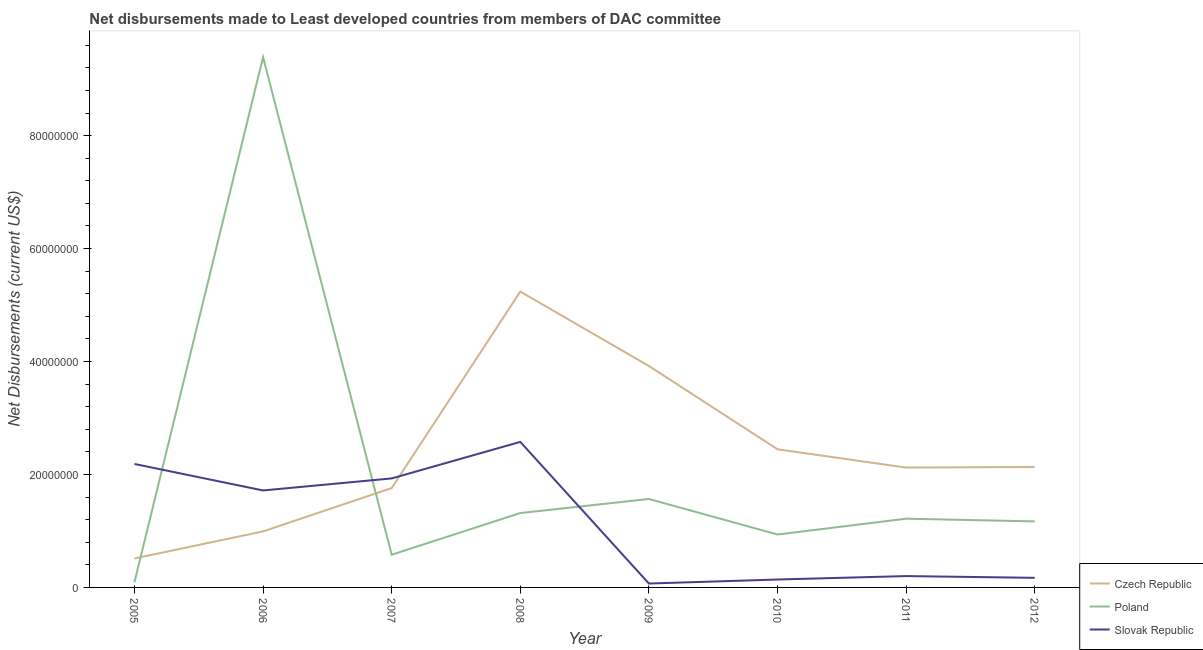How many different coloured lines are there?
Keep it short and to the point. 3. What is the net disbursements made by slovak republic in 2010?
Your answer should be very brief. 1.40e+06. Across all years, what is the maximum net disbursements made by czech republic?
Make the answer very short. 5.24e+07. Across all years, what is the minimum net disbursements made by czech republic?
Make the answer very short. 5.13e+06. What is the total net disbursements made by czech republic in the graph?
Your answer should be very brief. 1.91e+08. What is the difference between the net disbursements made by slovak republic in 2010 and that in 2012?
Ensure brevity in your answer.  -3.00e+05. What is the difference between the net disbursements made by poland in 2007 and the net disbursements made by czech republic in 2009?
Your response must be concise. -3.34e+07. What is the average net disbursements made by poland per year?
Provide a short and direct response. 2.03e+07. In the year 2011, what is the difference between the net disbursements made by czech republic and net disbursements made by poland?
Offer a terse response. 9.05e+06. In how many years, is the net disbursements made by slovak republic greater than 24000000 US$?
Ensure brevity in your answer.  1. What is the ratio of the net disbursements made by czech republic in 2006 to that in 2007?
Keep it short and to the point. 0.56. What is the difference between the highest and the second highest net disbursements made by poland?
Your answer should be very brief. 7.82e+07. What is the difference between the highest and the lowest net disbursements made by poland?
Ensure brevity in your answer.  9.30e+07. Is the sum of the net disbursements made by poland in 2008 and 2012 greater than the maximum net disbursements made by czech republic across all years?
Your answer should be compact. No. Does the net disbursements made by poland monotonically increase over the years?
Make the answer very short. No. Is the net disbursements made by poland strictly greater than the net disbursements made by czech republic over the years?
Provide a succinct answer. No. How many lines are there?
Provide a succinct answer. 3. Are the values on the major ticks of Y-axis written in scientific E-notation?
Make the answer very short. No. Does the graph contain any zero values?
Your answer should be compact. No. Where does the legend appear in the graph?
Ensure brevity in your answer.  Bottom right. How many legend labels are there?
Provide a succinct answer. 3. What is the title of the graph?
Offer a very short reply. Net disbursements made to Least developed countries from members of DAC committee. Does "Coal" appear as one of the legend labels in the graph?
Make the answer very short. No. What is the label or title of the Y-axis?
Your answer should be very brief. Net Disbursements (current US$). What is the Net Disbursements (current US$) of Czech Republic in 2005?
Your answer should be very brief. 5.13e+06. What is the Net Disbursements (current US$) in Poland in 2005?
Offer a very short reply. 9.30e+05. What is the Net Disbursements (current US$) of Slovak Republic in 2005?
Make the answer very short. 2.19e+07. What is the Net Disbursements (current US$) of Czech Republic in 2006?
Make the answer very short. 9.92e+06. What is the Net Disbursements (current US$) of Poland in 2006?
Provide a short and direct response. 9.39e+07. What is the Net Disbursements (current US$) of Slovak Republic in 2006?
Provide a short and direct response. 1.72e+07. What is the Net Disbursements (current US$) of Czech Republic in 2007?
Offer a very short reply. 1.76e+07. What is the Net Disbursements (current US$) in Poland in 2007?
Offer a terse response. 5.79e+06. What is the Net Disbursements (current US$) of Slovak Republic in 2007?
Offer a terse response. 1.93e+07. What is the Net Disbursements (current US$) of Czech Republic in 2008?
Make the answer very short. 5.24e+07. What is the Net Disbursements (current US$) of Poland in 2008?
Provide a succinct answer. 1.32e+07. What is the Net Disbursements (current US$) of Slovak Republic in 2008?
Give a very brief answer. 2.58e+07. What is the Net Disbursements (current US$) in Czech Republic in 2009?
Make the answer very short. 3.92e+07. What is the Net Disbursements (current US$) in Poland in 2009?
Your answer should be compact. 1.57e+07. What is the Net Disbursements (current US$) in Slovak Republic in 2009?
Your response must be concise. 6.90e+05. What is the Net Disbursements (current US$) of Czech Republic in 2010?
Your answer should be very brief. 2.45e+07. What is the Net Disbursements (current US$) in Poland in 2010?
Your answer should be very brief. 9.37e+06. What is the Net Disbursements (current US$) of Slovak Republic in 2010?
Offer a terse response. 1.40e+06. What is the Net Disbursements (current US$) in Czech Republic in 2011?
Offer a terse response. 2.12e+07. What is the Net Disbursements (current US$) in Poland in 2011?
Make the answer very short. 1.22e+07. What is the Net Disbursements (current US$) of Slovak Republic in 2011?
Give a very brief answer. 2.01e+06. What is the Net Disbursements (current US$) in Czech Republic in 2012?
Make the answer very short. 2.13e+07. What is the Net Disbursements (current US$) of Poland in 2012?
Ensure brevity in your answer.  1.17e+07. What is the Net Disbursements (current US$) in Slovak Republic in 2012?
Your response must be concise. 1.70e+06. Across all years, what is the maximum Net Disbursements (current US$) of Czech Republic?
Keep it short and to the point. 5.24e+07. Across all years, what is the maximum Net Disbursements (current US$) of Poland?
Make the answer very short. 9.39e+07. Across all years, what is the maximum Net Disbursements (current US$) in Slovak Republic?
Make the answer very short. 2.58e+07. Across all years, what is the minimum Net Disbursements (current US$) of Czech Republic?
Make the answer very short. 5.13e+06. Across all years, what is the minimum Net Disbursements (current US$) in Poland?
Your answer should be very brief. 9.30e+05. Across all years, what is the minimum Net Disbursements (current US$) in Slovak Republic?
Your response must be concise. 6.90e+05. What is the total Net Disbursements (current US$) of Czech Republic in the graph?
Provide a short and direct response. 1.91e+08. What is the total Net Disbursements (current US$) in Poland in the graph?
Provide a succinct answer. 1.63e+08. What is the total Net Disbursements (current US$) in Slovak Republic in the graph?
Make the answer very short. 8.99e+07. What is the difference between the Net Disbursements (current US$) of Czech Republic in 2005 and that in 2006?
Your answer should be very brief. -4.79e+06. What is the difference between the Net Disbursements (current US$) of Poland in 2005 and that in 2006?
Ensure brevity in your answer.  -9.30e+07. What is the difference between the Net Disbursements (current US$) of Slovak Republic in 2005 and that in 2006?
Your answer should be compact. 4.69e+06. What is the difference between the Net Disbursements (current US$) in Czech Republic in 2005 and that in 2007?
Your answer should be compact. -1.25e+07. What is the difference between the Net Disbursements (current US$) in Poland in 2005 and that in 2007?
Keep it short and to the point. -4.86e+06. What is the difference between the Net Disbursements (current US$) of Slovak Republic in 2005 and that in 2007?
Ensure brevity in your answer.  2.56e+06. What is the difference between the Net Disbursements (current US$) in Czech Republic in 2005 and that in 2008?
Your answer should be compact. -4.72e+07. What is the difference between the Net Disbursements (current US$) of Poland in 2005 and that in 2008?
Offer a terse response. -1.22e+07. What is the difference between the Net Disbursements (current US$) in Slovak Republic in 2005 and that in 2008?
Provide a succinct answer. -3.91e+06. What is the difference between the Net Disbursements (current US$) in Czech Republic in 2005 and that in 2009?
Give a very brief answer. -3.41e+07. What is the difference between the Net Disbursements (current US$) of Poland in 2005 and that in 2009?
Keep it short and to the point. -1.47e+07. What is the difference between the Net Disbursements (current US$) of Slovak Republic in 2005 and that in 2009?
Your answer should be compact. 2.12e+07. What is the difference between the Net Disbursements (current US$) of Czech Republic in 2005 and that in 2010?
Provide a succinct answer. -1.93e+07. What is the difference between the Net Disbursements (current US$) of Poland in 2005 and that in 2010?
Your answer should be very brief. -8.44e+06. What is the difference between the Net Disbursements (current US$) of Slovak Republic in 2005 and that in 2010?
Provide a succinct answer. 2.05e+07. What is the difference between the Net Disbursements (current US$) of Czech Republic in 2005 and that in 2011?
Provide a succinct answer. -1.61e+07. What is the difference between the Net Disbursements (current US$) in Poland in 2005 and that in 2011?
Make the answer very short. -1.12e+07. What is the difference between the Net Disbursements (current US$) in Slovak Republic in 2005 and that in 2011?
Offer a terse response. 1.98e+07. What is the difference between the Net Disbursements (current US$) in Czech Republic in 2005 and that in 2012?
Give a very brief answer. -1.62e+07. What is the difference between the Net Disbursements (current US$) in Poland in 2005 and that in 2012?
Offer a very short reply. -1.08e+07. What is the difference between the Net Disbursements (current US$) in Slovak Republic in 2005 and that in 2012?
Your answer should be compact. 2.02e+07. What is the difference between the Net Disbursements (current US$) of Czech Republic in 2006 and that in 2007?
Give a very brief answer. -7.67e+06. What is the difference between the Net Disbursements (current US$) of Poland in 2006 and that in 2007?
Your answer should be compact. 8.81e+07. What is the difference between the Net Disbursements (current US$) of Slovak Republic in 2006 and that in 2007?
Your response must be concise. -2.13e+06. What is the difference between the Net Disbursements (current US$) in Czech Republic in 2006 and that in 2008?
Your answer should be compact. -4.25e+07. What is the difference between the Net Disbursements (current US$) in Poland in 2006 and that in 2008?
Provide a succinct answer. 8.07e+07. What is the difference between the Net Disbursements (current US$) of Slovak Republic in 2006 and that in 2008?
Offer a terse response. -8.60e+06. What is the difference between the Net Disbursements (current US$) in Czech Republic in 2006 and that in 2009?
Ensure brevity in your answer.  -2.93e+07. What is the difference between the Net Disbursements (current US$) of Poland in 2006 and that in 2009?
Offer a very short reply. 7.82e+07. What is the difference between the Net Disbursements (current US$) in Slovak Republic in 2006 and that in 2009?
Offer a very short reply. 1.65e+07. What is the difference between the Net Disbursements (current US$) in Czech Republic in 2006 and that in 2010?
Offer a very short reply. -1.45e+07. What is the difference between the Net Disbursements (current US$) of Poland in 2006 and that in 2010?
Offer a very short reply. 8.45e+07. What is the difference between the Net Disbursements (current US$) of Slovak Republic in 2006 and that in 2010?
Make the answer very short. 1.58e+07. What is the difference between the Net Disbursements (current US$) of Czech Republic in 2006 and that in 2011?
Offer a very short reply. -1.13e+07. What is the difference between the Net Disbursements (current US$) of Poland in 2006 and that in 2011?
Your answer should be compact. 8.17e+07. What is the difference between the Net Disbursements (current US$) of Slovak Republic in 2006 and that in 2011?
Your answer should be compact. 1.52e+07. What is the difference between the Net Disbursements (current US$) in Czech Republic in 2006 and that in 2012?
Your response must be concise. -1.14e+07. What is the difference between the Net Disbursements (current US$) in Poland in 2006 and that in 2012?
Ensure brevity in your answer.  8.22e+07. What is the difference between the Net Disbursements (current US$) in Slovak Republic in 2006 and that in 2012?
Provide a succinct answer. 1.55e+07. What is the difference between the Net Disbursements (current US$) of Czech Republic in 2007 and that in 2008?
Your response must be concise. -3.48e+07. What is the difference between the Net Disbursements (current US$) in Poland in 2007 and that in 2008?
Offer a terse response. -7.38e+06. What is the difference between the Net Disbursements (current US$) of Slovak Republic in 2007 and that in 2008?
Your answer should be compact. -6.47e+06. What is the difference between the Net Disbursements (current US$) of Czech Republic in 2007 and that in 2009?
Offer a terse response. -2.16e+07. What is the difference between the Net Disbursements (current US$) in Poland in 2007 and that in 2009?
Your answer should be compact. -9.87e+06. What is the difference between the Net Disbursements (current US$) of Slovak Republic in 2007 and that in 2009?
Offer a very short reply. 1.86e+07. What is the difference between the Net Disbursements (current US$) in Czech Republic in 2007 and that in 2010?
Keep it short and to the point. -6.87e+06. What is the difference between the Net Disbursements (current US$) of Poland in 2007 and that in 2010?
Ensure brevity in your answer.  -3.58e+06. What is the difference between the Net Disbursements (current US$) of Slovak Republic in 2007 and that in 2010?
Make the answer very short. 1.79e+07. What is the difference between the Net Disbursements (current US$) in Czech Republic in 2007 and that in 2011?
Make the answer very short. -3.63e+06. What is the difference between the Net Disbursements (current US$) in Poland in 2007 and that in 2011?
Your answer should be very brief. -6.38e+06. What is the difference between the Net Disbursements (current US$) in Slovak Republic in 2007 and that in 2011?
Your answer should be very brief. 1.73e+07. What is the difference between the Net Disbursements (current US$) in Czech Republic in 2007 and that in 2012?
Offer a terse response. -3.74e+06. What is the difference between the Net Disbursements (current US$) in Poland in 2007 and that in 2012?
Your answer should be very brief. -5.90e+06. What is the difference between the Net Disbursements (current US$) in Slovak Republic in 2007 and that in 2012?
Offer a very short reply. 1.76e+07. What is the difference between the Net Disbursements (current US$) in Czech Republic in 2008 and that in 2009?
Offer a very short reply. 1.32e+07. What is the difference between the Net Disbursements (current US$) of Poland in 2008 and that in 2009?
Offer a very short reply. -2.49e+06. What is the difference between the Net Disbursements (current US$) in Slovak Republic in 2008 and that in 2009?
Offer a terse response. 2.51e+07. What is the difference between the Net Disbursements (current US$) of Czech Republic in 2008 and that in 2010?
Ensure brevity in your answer.  2.79e+07. What is the difference between the Net Disbursements (current US$) in Poland in 2008 and that in 2010?
Keep it short and to the point. 3.80e+06. What is the difference between the Net Disbursements (current US$) in Slovak Republic in 2008 and that in 2010?
Your answer should be compact. 2.44e+07. What is the difference between the Net Disbursements (current US$) of Czech Republic in 2008 and that in 2011?
Your answer should be very brief. 3.12e+07. What is the difference between the Net Disbursements (current US$) of Poland in 2008 and that in 2011?
Make the answer very short. 1.00e+06. What is the difference between the Net Disbursements (current US$) of Slovak Republic in 2008 and that in 2011?
Make the answer very short. 2.38e+07. What is the difference between the Net Disbursements (current US$) in Czech Republic in 2008 and that in 2012?
Provide a succinct answer. 3.10e+07. What is the difference between the Net Disbursements (current US$) of Poland in 2008 and that in 2012?
Offer a very short reply. 1.48e+06. What is the difference between the Net Disbursements (current US$) of Slovak Republic in 2008 and that in 2012?
Your response must be concise. 2.41e+07. What is the difference between the Net Disbursements (current US$) in Czech Republic in 2009 and that in 2010?
Your answer should be very brief. 1.48e+07. What is the difference between the Net Disbursements (current US$) of Poland in 2009 and that in 2010?
Ensure brevity in your answer.  6.29e+06. What is the difference between the Net Disbursements (current US$) in Slovak Republic in 2009 and that in 2010?
Ensure brevity in your answer.  -7.10e+05. What is the difference between the Net Disbursements (current US$) in Czech Republic in 2009 and that in 2011?
Provide a short and direct response. 1.80e+07. What is the difference between the Net Disbursements (current US$) of Poland in 2009 and that in 2011?
Provide a succinct answer. 3.49e+06. What is the difference between the Net Disbursements (current US$) of Slovak Republic in 2009 and that in 2011?
Offer a terse response. -1.32e+06. What is the difference between the Net Disbursements (current US$) of Czech Republic in 2009 and that in 2012?
Keep it short and to the point. 1.79e+07. What is the difference between the Net Disbursements (current US$) in Poland in 2009 and that in 2012?
Provide a short and direct response. 3.97e+06. What is the difference between the Net Disbursements (current US$) of Slovak Republic in 2009 and that in 2012?
Offer a terse response. -1.01e+06. What is the difference between the Net Disbursements (current US$) in Czech Republic in 2010 and that in 2011?
Provide a succinct answer. 3.24e+06. What is the difference between the Net Disbursements (current US$) in Poland in 2010 and that in 2011?
Your response must be concise. -2.80e+06. What is the difference between the Net Disbursements (current US$) in Slovak Republic in 2010 and that in 2011?
Your answer should be compact. -6.10e+05. What is the difference between the Net Disbursements (current US$) of Czech Republic in 2010 and that in 2012?
Give a very brief answer. 3.13e+06. What is the difference between the Net Disbursements (current US$) of Poland in 2010 and that in 2012?
Offer a very short reply. -2.32e+06. What is the difference between the Net Disbursements (current US$) in Slovak Republic in 2010 and that in 2012?
Your response must be concise. -3.00e+05. What is the difference between the Net Disbursements (current US$) in Czech Republic in 2011 and that in 2012?
Your answer should be very brief. -1.10e+05. What is the difference between the Net Disbursements (current US$) of Czech Republic in 2005 and the Net Disbursements (current US$) of Poland in 2006?
Give a very brief answer. -8.88e+07. What is the difference between the Net Disbursements (current US$) of Czech Republic in 2005 and the Net Disbursements (current US$) of Slovak Republic in 2006?
Offer a terse response. -1.20e+07. What is the difference between the Net Disbursements (current US$) in Poland in 2005 and the Net Disbursements (current US$) in Slovak Republic in 2006?
Your answer should be very brief. -1.62e+07. What is the difference between the Net Disbursements (current US$) in Czech Republic in 2005 and the Net Disbursements (current US$) in Poland in 2007?
Offer a terse response. -6.60e+05. What is the difference between the Net Disbursements (current US$) of Czech Republic in 2005 and the Net Disbursements (current US$) of Slovak Republic in 2007?
Provide a succinct answer. -1.42e+07. What is the difference between the Net Disbursements (current US$) in Poland in 2005 and the Net Disbursements (current US$) in Slovak Republic in 2007?
Your answer should be very brief. -1.84e+07. What is the difference between the Net Disbursements (current US$) in Czech Republic in 2005 and the Net Disbursements (current US$) in Poland in 2008?
Your answer should be compact. -8.04e+06. What is the difference between the Net Disbursements (current US$) in Czech Republic in 2005 and the Net Disbursements (current US$) in Slovak Republic in 2008?
Offer a very short reply. -2.06e+07. What is the difference between the Net Disbursements (current US$) of Poland in 2005 and the Net Disbursements (current US$) of Slovak Republic in 2008?
Your answer should be very brief. -2.48e+07. What is the difference between the Net Disbursements (current US$) in Czech Republic in 2005 and the Net Disbursements (current US$) in Poland in 2009?
Give a very brief answer. -1.05e+07. What is the difference between the Net Disbursements (current US$) in Czech Republic in 2005 and the Net Disbursements (current US$) in Slovak Republic in 2009?
Give a very brief answer. 4.44e+06. What is the difference between the Net Disbursements (current US$) of Poland in 2005 and the Net Disbursements (current US$) of Slovak Republic in 2009?
Your response must be concise. 2.40e+05. What is the difference between the Net Disbursements (current US$) of Czech Republic in 2005 and the Net Disbursements (current US$) of Poland in 2010?
Provide a succinct answer. -4.24e+06. What is the difference between the Net Disbursements (current US$) of Czech Republic in 2005 and the Net Disbursements (current US$) of Slovak Republic in 2010?
Offer a very short reply. 3.73e+06. What is the difference between the Net Disbursements (current US$) in Poland in 2005 and the Net Disbursements (current US$) in Slovak Republic in 2010?
Keep it short and to the point. -4.70e+05. What is the difference between the Net Disbursements (current US$) of Czech Republic in 2005 and the Net Disbursements (current US$) of Poland in 2011?
Keep it short and to the point. -7.04e+06. What is the difference between the Net Disbursements (current US$) of Czech Republic in 2005 and the Net Disbursements (current US$) of Slovak Republic in 2011?
Make the answer very short. 3.12e+06. What is the difference between the Net Disbursements (current US$) in Poland in 2005 and the Net Disbursements (current US$) in Slovak Republic in 2011?
Provide a short and direct response. -1.08e+06. What is the difference between the Net Disbursements (current US$) in Czech Republic in 2005 and the Net Disbursements (current US$) in Poland in 2012?
Your response must be concise. -6.56e+06. What is the difference between the Net Disbursements (current US$) of Czech Republic in 2005 and the Net Disbursements (current US$) of Slovak Republic in 2012?
Make the answer very short. 3.43e+06. What is the difference between the Net Disbursements (current US$) of Poland in 2005 and the Net Disbursements (current US$) of Slovak Republic in 2012?
Offer a terse response. -7.70e+05. What is the difference between the Net Disbursements (current US$) in Czech Republic in 2006 and the Net Disbursements (current US$) in Poland in 2007?
Give a very brief answer. 4.13e+06. What is the difference between the Net Disbursements (current US$) of Czech Republic in 2006 and the Net Disbursements (current US$) of Slovak Republic in 2007?
Keep it short and to the point. -9.38e+06. What is the difference between the Net Disbursements (current US$) in Poland in 2006 and the Net Disbursements (current US$) in Slovak Republic in 2007?
Provide a succinct answer. 7.46e+07. What is the difference between the Net Disbursements (current US$) in Czech Republic in 2006 and the Net Disbursements (current US$) in Poland in 2008?
Offer a very short reply. -3.25e+06. What is the difference between the Net Disbursements (current US$) in Czech Republic in 2006 and the Net Disbursements (current US$) in Slovak Republic in 2008?
Give a very brief answer. -1.58e+07. What is the difference between the Net Disbursements (current US$) of Poland in 2006 and the Net Disbursements (current US$) of Slovak Republic in 2008?
Your answer should be compact. 6.81e+07. What is the difference between the Net Disbursements (current US$) of Czech Republic in 2006 and the Net Disbursements (current US$) of Poland in 2009?
Give a very brief answer. -5.74e+06. What is the difference between the Net Disbursements (current US$) in Czech Republic in 2006 and the Net Disbursements (current US$) in Slovak Republic in 2009?
Provide a succinct answer. 9.23e+06. What is the difference between the Net Disbursements (current US$) in Poland in 2006 and the Net Disbursements (current US$) in Slovak Republic in 2009?
Your answer should be compact. 9.32e+07. What is the difference between the Net Disbursements (current US$) of Czech Republic in 2006 and the Net Disbursements (current US$) of Poland in 2010?
Your answer should be very brief. 5.50e+05. What is the difference between the Net Disbursements (current US$) of Czech Republic in 2006 and the Net Disbursements (current US$) of Slovak Republic in 2010?
Offer a terse response. 8.52e+06. What is the difference between the Net Disbursements (current US$) of Poland in 2006 and the Net Disbursements (current US$) of Slovak Republic in 2010?
Ensure brevity in your answer.  9.25e+07. What is the difference between the Net Disbursements (current US$) in Czech Republic in 2006 and the Net Disbursements (current US$) in Poland in 2011?
Offer a very short reply. -2.25e+06. What is the difference between the Net Disbursements (current US$) in Czech Republic in 2006 and the Net Disbursements (current US$) in Slovak Republic in 2011?
Offer a terse response. 7.91e+06. What is the difference between the Net Disbursements (current US$) in Poland in 2006 and the Net Disbursements (current US$) in Slovak Republic in 2011?
Give a very brief answer. 9.19e+07. What is the difference between the Net Disbursements (current US$) in Czech Republic in 2006 and the Net Disbursements (current US$) in Poland in 2012?
Provide a succinct answer. -1.77e+06. What is the difference between the Net Disbursements (current US$) in Czech Republic in 2006 and the Net Disbursements (current US$) in Slovak Republic in 2012?
Give a very brief answer. 8.22e+06. What is the difference between the Net Disbursements (current US$) in Poland in 2006 and the Net Disbursements (current US$) in Slovak Republic in 2012?
Your answer should be compact. 9.22e+07. What is the difference between the Net Disbursements (current US$) of Czech Republic in 2007 and the Net Disbursements (current US$) of Poland in 2008?
Your response must be concise. 4.42e+06. What is the difference between the Net Disbursements (current US$) of Czech Republic in 2007 and the Net Disbursements (current US$) of Slovak Republic in 2008?
Your response must be concise. -8.18e+06. What is the difference between the Net Disbursements (current US$) of Poland in 2007 and the Net Disbursements (current US$) of Slovak Republic in 2008?
Provide a succinct answer. -2.00e+07. What is the difference between the Net Disbursements (current US$) of Czech Republic in 2007 and the Net Disbursements (current US$) of Poland in 2009?
Provide a succinct answer. 1.93e+06. What is the difference between the Net Disbursements (current US$) of Czech Republic in 2007 and the Net Disbursements (current US$) of Slovak Republic in 2009?
Your answer should be compact. 1.69e+07. What is the difference between the Net Disbursements (current US$) of Poland in 2007 and the Net Disbursements (current US$) of Slovak Republic in 2009?
Provide a short and direct response. 5.10e+06. What is the difference between the Net Disbursements (current US$) of Czech Republic in 2007 and the Net Disbursements (current US$) of Poland in 2010?
Your response must be concise. 8.22e+06. What is the difference between the Net Disbursements (current US$) of Czech Republic in 2007 and the Net Disbursements (current US$) of Slovak Republic in 2010?
Your response must be concise. 1.62e+07. What is the difference between the Net Disbursements (current US$) in Poland in 2007 and the Net Disbursements (current US$) in Slovak Republic in 2010?
Your response must be concise. 4.39e+06. What is the difference between the Net Disbursements (current US$) of Czech Republic in 2007 and the Net Disbursements (current US$) of Poland in 2011?
Keep it short and to the point. 5.42e+06. What is the difference between the Net Disbursements (current US$) of Czech Republic in 2007 and the Net Disbursements (current US$) of Slovak Republic in 2011?
Make the answer very short. 1.56e+07. What is the difference between the Net Disbursements (current US$) of Poland in 2007 and the Net Disbursements (current US$) of Slovak Republic in 2011?
Provide a short and direct response. 3.78e+06. What is the difference between the Net Disbursements (current US$) in Czech Republic in 2007 and the Net Disbursements (current US$) in Poland in 2012?
Offer a very short reply. 5.90e+06. What is the difference between the Net Disbursements (current US$) of Czech Republic in 2007 and the Net Disbursements (current US$) of Slovak Republic in 2012?
Provide a succinct answer. 1.59e+07. What is the difference between the Net Disbursements (current US$) in Poland in 2007 and the Net Disbursements (current US$) in Slovak Republic in 2012?
Provide a succinct answer. 4.09e+06. What is the difference between the Net Disbursements (current US$) of Czech Republic in 2008 and the Net Disbursements (current US$) of Poland in 2009?
Offer a very short reply. 3.67e+07. What is the difference between the Net Disbursements (current US$) of Czech Republic in 2008 and the Net Disbursements (current US$) of Slovak Republic in 2009?
Your answer should be compact. 5.17e+07. What is the difference between the Net Disbursements (current US$) of Poland in 2008 and the Net Disbursements (current US$) of Slovak Republic in 2009?
Provide a succinct answer. 1.25e+07. What is the difference between the Net Disbursements (current US$) of Czech Republic in 2008 and the Net Disbursements (current US$) of Poland in 2010?
Your answer should be compact. 4.30e+07. What is the difference between the Net Disbursements (current US$) of Czech Republic in 2008 and the Net Disbursements (current US$) of Slovak Republic in 2010?
Your response must be concise. 5.10e+07. What is the difference between the Net Disbursements (current US$) of Poland in 2008 and the Net Disbursements (current US$) of Slovak Republic in 2010?
Make the answer very short. 1.18e+07. What is the difference between the Net Disbursements (current US$) of Czech Republic in 2008 and the Net Disbursements (current US$) of Poland in 2011?
Offer a terse response. 4.02e+07. What is the difference between the Net Disbursements (current US$) in Czech Republic in 2008 and the Net Disbursements (current US$) in Slovak Republic in 2011?
Make the answer very short. 5.04e+07. What is the difference between the Net Disbursements (current US$) of Poland in 2008 and the Net Disbursements (current US$) of Slovak Republic in 2011?
Give a very brief answer. 1.12e+07. What is the difference between the Net Disbursements (current US$) of Czech Republic in 2008 and the Net Disbursements (current US$) of Poland in 2012?
Make the answer very short. 4.07e+07. What is the difference between the Net Disbursements (current US$) of Czech Republic in 2008 and the Net Disbursements (current US$) of Slovak Republic in 2012?
Provide a succinct answer. 5.07e+07. What is the difference between the Net Disbursements (current US$) of Poland in 2008 and the Net Disbursements (current US$) of Slovak Republic in 2012?
Give a very brief answer. 1.15e+07. What is the difference between the Net Disbursements (current US$) in Czech Republic in 2009 and the Net Disbursements (current US$) in Poland in 2010?
Keep it short and to the point. 2.98e+07. What is the difference between the Net Disbursements (current US$) in Czech Republic in 2009 and the Net Disbursements (current US$) in Slovak Republic in 2010?
Your response must be concise. 3.78e+07. What is the difference between the Net Disbursements (current US$) of Poland in 2009 and the Net Disbursements (current US$) of Slovak Republic in 2010?
Offer a very short reply. 1.43e+07. What is the difference between the Net Disbursements (current US$) of Czech Republic in 2009 and the Net Disbursements (current US$) of Poland in 2011?
Ensure brevity in your answer.  2.70e+07. What is the difference between the Net Disbursements (current US$) of Czech Republic in 2009 and the Net Disbursements (current US$) of Slovak Republic in 2011?
Give a very brief answer. 3.72e+07. What is the difference between the Net Disbursements (current US$) in Poland in 2009 and the Net Disbursements (current US$) in Slovak Republic in 2011?
Your response must be concise. 1.36e+07. What is the difference between the Net Disbursements (current US$) in Czech Republic in 2009 and the Net Disbursements (current US$) in Poland in 2012?
Make the answer very short. 2.75e+07. What is the difference between the Net Disbursements (current US$) in Czech Republic in 2009 and the Net Disbursements (current US$) in Slovak Republic in 2012?
Ensure brevity in your answer.  3.75e+07. What is the difference between the Net Disbursements (current US$) of Poland in 2009 and the Net Disbursements (current US$) of Slovak Republic in 2012?
Keep it short and to the point. 1.40e+07. What is the difference between the Net Disbursements (current US$) of Czech Republic in 2010 and the Net Disbursements (current US$) of Poland in 2011?
Offer a terse response. 1.23e+07. What is the difference between the Net Disbursements (current US$) in Czech Republic in 2010 and the Net Disbursements (current US$) in Slovak Republic in 2011?
Your answer should be compact. 2.24e+07. What is the difference between the Net Disbursements (current US$) in Poland in 2010 and the Net Disbursements (current US$) in Slovak Republic in 2011?
Your response must be concise. 7.36e+06. What is the difference between the Net Disbursements (current US$) in Czech Republic in 2010 and the Net Disbursements (current US$) in Poland in 2012?
Provide a short and direct response. 1.28e+07. What is the difference between the Net Disbursements (current US$) in Czech Republic in 2010 and the Net Disbursements (current US$) in Slovak Republic in 2012?
Your answer should be very brief. 2.28e+07. What is the difference between the Net Disbursements (current US$) of Poland in 2010 and the Net Disbursements (current US$) of Slovak Republic in 2012?
Provide a short and direct response. 7.67e+06. What is the difference between the Net Disbursements (current US$) in Czech Republic in 2011 and the Net Disbursements (current US$) in Poland in 2012?
Ensure brevity in your answer.  9.53e+06. What is the difference between the Net Disbursements (current US$) of Czech Republic in 2011 and the Net Disbursements (current US$) of Slovak Republic in 2012?
Give a very brief answer. 1.95e+07. What is the difference between the Net Disbursements (current US$) in Poland in 2011 and the Net Disbursements (current US$) in Slovak Republic in 2012?
Offer a very short reply. 1.05e+07. What is the average Net Disbursements (current US$) of Czech Republic per year?
Provide a short and direct response. 2.39e+07. What is the average Net Disbursements (current US$) in Poland per year?
Your response must be concise. 2.03e+07. What is the average Net Disbursements (current US$) in Slovak Republic per year?
Offer a very short reply. 1.12e+07. In the year 2005, what is the difference between the Net Disbursements (current US$) of Czech Republic and Net Disbursements (current US$) of Poland?
Ensure brevity in your answer.  4.20e+06. In the year 2005, what is the difference between the Net Disbursements (current US$) of Czech Republic and Net Disbursements (current US$) of Slovak Republic?
Offer a very short reply. -1.67e+07. In the year 2005, what is the difference between the Net Disbursements (current US$) in Poland and Net Disbursements (current US$) in Slovak Republic?
Give a very brief answer. -2.09e+07. In the year 2006, what is the difference between the Net Disbursements (current US$) in Czech Republic and Net Disbursements (current US$) in Poland?
Keep it short and to the point. -8.40e+07. In the year 2006, what is the difference between the Net Disbursements (current US$) in Czech Republic and Net Disbursements (current US$) in Slovak Republic?
Keep it short and to the point. -7.25e+06. In the year 2006, what is the difference between the Net Disbursements (current US$) of Poland and Net Disbursements (current US$) of Slovak Republic?
Provide a succinct answer. 7.67e+07. In the year 2007, what is the difference between the Net Disbursements (current US$) of Czech Republic and Net Disbursements (current US$) of Poland?
Provide a short and direct response. 1.18e+07. In the year 2007, what is the difference between the Net Disbursements (current US$) in Czech Republic and Net Disbursements (current US$) in Slovak Republic?
Give a very brief answer. -1.71e+06. In the year 2007, what is the difference between the Net Disbursements (current US$) of Poland and Net Disbursements (current US$) of Slovak Republic?
Ensure brevity in your answer.  -1.35e+07. In the year 2008, what is the difference between the Net Disbursements (current US$) of Czech Republic and Net Disbursements (current US$) of Poland?
Give a very brief answer. 3.92e+07. In the year 2008, what is the difference between the Net Disbursements (current US$) in Czech Republic and Net Disbursements (current US$) in Slovak Republic?
Offer a very short reply. 2.66e+07. In the year 2008, what is the difference between the Net Disbursements (current US$) in Poland and Net Disbursements (current US$) in Slovak Republic?
Provide a succinct answer. -1.26e+07. In the year 2009, what is the difference between the Net Disbursements (current US$) of Czech Republic and Net Disbursements (current US$) of Poland?
Your answer should be very brief. 2.36e+07. In the year 2009, what is the difference between the Net Disbursements (current US$) of Czech Republic and Net Disbursements (current US$) of Slovak Republic?
Make the answer very short. 3.85e+07. In the year 2009, what is the difference between the Net Disbursements (current US$) of Poland and Net Disbursements (current US$) of Slovak Republic?
Give a very brief answer. 1.50e+07. In the year 2010, what is the difference between the Net Disbursements (current US$) in Czech Republic and Net Disbursements (current US$) in Poland?
Provide a succinct answer. 1.51e+07. In the year 2010, what is the difference between the Net Disbursements (current US$) of Czech Republic and Net Disbursements (current US$) of Slovak Republic?
Your response must be concise. 2.31e+07. In the year 2010, what is the difference between the Net Disbursements (current US$) in Poland and Net Disbursements (current US$) in Slovak Republic?
Your response must be concise. 7.97e+06. In the year 2011, what is the difference between the Net Disbursements (current US$) in Czech Republic and Net Disbursements (current US$) in Poland?
Ensure brevity in your answer.  9.05e+06. In the year 2011, what is the difference between the Net Disbursements (current US$) in Czech Republic and Net Disbursements (current US$) in Slovak Republic?
Ensure brevity in your answer.  1.92e+07. In the year 2011, what is the difference between the Net Disbursements (current US$) of Poland and Net Disbursements (current US$) of Slovak Republic?
Make the answer very short. 1.02e+07. In the year 2012, what is the difference between the Net Disbursements (current US$) in Czech Republic and Net Disbursements (current US$) in Poland?
Provide a short and direct response. 9.64e+06. In the year 2012, what is the difference between the Net Disbursements (current US$) in Czech Republic and Net Disbursements (current US$) in Slovak Republic?
Ensure brevity in your answer.  1.96e+07. In the year 2012, what is the difference between the Net Disbursements (current US$) in Poland and Net Disbursements (current US$) in Slovak Republic?
Your answer should be very brief. 9.99e+06. What is the ratio of the Net Disbursements (current US$) of Czech Republic in 2005 to that in 2006?
Provide a short and direct response. 0.52. What is the ratio of the Net Disbursements (current US$) of Poland in 2005 to that in 2006?
Offer a terse response. 0.01. What is the ratio of the Net Disbursements (current US$) of Slovak Republic in 2005 to that in 2006?
Your answer should be very brief. 1.27. What is the ratio of the Net Disbursements (current US$) of Czech Republic in 2005 to that in 2007?
Provide a succinct answer. 0.29. What is the ratio of the Net Disbursements (current US$) of Poland in 2005 to that in 2007?
Make the answer very short. 0.16. What is the ratio of the Net Disbursements (current US$) of Slovak Republic in 2005 to that in 2007?
Offer a terse response. 1.13. What is the ratio of the Net Disbursements (current US$) in Czech Republic in 2005 to that in 2008?
Provide a short and direct response. 0.1. What is the ratio of the Net Disbursements (current US$) of Poland in 2005 to that in 2008?
Your answer should be compact. 0.07. What is the ratio of the Net Disbursements (current US$) in Slovak Republic in 2005 to that in 2008?
Make the answer very short. 0.85. What is the ratio of the Net Disbursements (current US$) in Czech Republic in 2005 to that in 2009?
Ensure brevity in your answer.  0.13. What is the ratio of the Net Disbursements (current US$) in Poland in 2005 to that in 2009?
Offer a terse response. 0.06. What is the ratio of the Net Disbursements (current US$) of Slovak Republic in 2005 to that in 2009?
Your answer should be compact. 31.68. What is the ratio of the Net Disbursements (current US$) in Czech Republic in 2005 to that in 2010?
Offer a terse response. 0.21. What is the ratio of the Net Disbursements (current US$) of Poland in 2005 to that in 2010?
Make the answer very short. 0.1. What is the ratio of the Net Disbursements (current US$) of Slovak Republic in 2005 to that in 2010?
Keep it short and to the point. 15.61. What is the ratio of the Net Disbursements (current US$) of Czech Republic in 2005 to that in 2011?
Your answer should be very brief. 0.24. What is the ratio of the Net Disbursements (current US$) in Poland in 2005 to that in 2011?
Make the answer very short. 0.08. What is the ratio of the Net Disbursements (current US$) in Slovak Republic in 2005 to that in 2011?
Keep it short and to the point. 10.88. What is the ratio of the Net Disbursements (current US$) in Czech Republic in 2005 to that in 2012?
Your answer should be compact. 0.24. What is the ratio of the Net Disbursements (current US$) of Poland in 2005 to that in 2012?
Provide a succinct answer. 0.08. What is the ratio of the Net Disbursements (current US$) in Slovak Republic in 2005 to that in 2012?
Your answer should be compact. 12.86. What is the ratio of the Net Disbursements (current US$) of Czech Republic in 2006 to that in 2007?
Keep it short and to the point. 0.56. What is the ratio of the Net Disbursements (current US$) of Poland in 2006 to that in 2007?
Your answer should be compact. 16.22. What is the ratio of the Net Disbursements (current US$) in Slovak Republic in 2006 to that in 2007?
Keep it short and to the point. 0.89. What is the ratio of the Net Disbursements (current US$) of Czech Republic in 2006 to that in 2008?
Offer a terse response. 0.19. What is the ratio of the Net Disbursements (current US$) of Poland in 2006 to that in 2008?
Your response must be concise. 7.13. What is the ratio of the Net Disbursements (current US$) in Slovak Republic in 2006 to that in 2008?
Give a very brief answer. 0.67. What is the ratio of the Net Disbursements (current US$) in Czech Republic in 2006 to that in 2009?
Your answer should be very brief. 0.25. What is the ratio of the Net Disbursements (current US$) of Poland in 2006 to that in 2009?
Offer a terse response. 6. What is the ratio of the Net Disbursements (current US$) in Slovak Republic in 2006 to that in 2009?
Give a very brief answer. 24.88. What is the ratio of the Net Disbursements (current US$) in Czech Republic in 2006 to that in 2010?
Offer a very short reply. 0.41. What is the ratio of the Net Disbursements (current US$) in Poland in 2006 to that in 2010?
Provide a short and direct response. 10.02. What is the ratio of the Net Disbursements (current US$) in Slovak Republic in 2006 to that in 2010?
Your answer should be very brief. 12.26. What is the ratio of the Net Disbursements (current US$) in Czech Republic in 2006 to that in 2011?
Provide a succinct answer. 0.47. What is the ratio of the Net Disbursements (current US$) of Poland in 2006 to that in 2011?
Make the answer very short. 7.71. What is the ratio of the Net Disbursements (current US$) of Slovak Republic in 2006 to that in 2011?
Offer a terse response. 8.54. What is the ratio of the Net Disbursements (current US$) of Czech Republic in 2006 to that in 2012?
Ensure brevity in your answer.  0.47. What is the ratio of the Net Disbursements (current US$) of Poland in 2006 to that in 2012?
Offer a very short reply. 8.03. What is the ratio of the Net Disbursements (current US$) in Czech Republic in 2007 to that in 2008?
Your answer should be very brief. 0.34. What is the ratio of the Net Disbursements (current US$) in Poland in 2007 to that in 2008?
Provide a succinct answer. 0.44. What is the ratio of the Net Disbursements (current US$) in Slovak Republic in 2007 to that in 2008?
Your answer should be compact. 0.75. What is the ratio of the Net Disbursements (current US$) of Czech Republic in 2007 to that in 2009?
Your answer should be compact. 0.45. What is the ratio of the Net Disbursements (current US$) of Poland in 2007 to that in 2009?
Keep it short and to the point. 0.37. What is the ratio of the Net Disbursements (current US$) of Slovak Republic in 2007 to that in 2009?
Your response must be concise. 27.97. What is the ratio of the Net Disbursements (current US$) of Czech Republic in 2007 to that in 2010?
Offer a very short reply. 0.72. What is the ratio of the Net Disbursements (current US$) in Poland in 2007 to that in 2010?
Offer a very short reply. 0.62. What is the ratio of the Net Disbursements (current US$) of Slovak Republic in 2007 to that in 2010?
Your answer should be very brief. 13.79. What is the ratio of the Net Disbursements (current US$) in Czech Republic in 2007 to that in 2011?
Give a very brief answer. 0.83. What is the ratio of the Net Disbursements (current US$) of Poland in 2007 to that in 2011?
Your answer should be very brief. 0.48. What is the ratio of the Net Disbursements (current US$) of Slovak Republic in 2007 to that in 2011?
Your response must be concise. 9.6. What is the ratio of the Net Disbursements (current US$) in Czech Republic in 2007 to that in 2012?
Make the answer very short. 0.82. What is the ratio of the Net Disbursements (current US$) of Poland in 2007 to that in 2012?
Offer a terse response. 0.5. What is the ratio of the Net Disbursements (current US$) in Slovak Republic in 2007 to that in 2012?
Keep it short and to the point. 11.35. What is the ratio of the Net Disbursements (current US$) in Czech Republic in 2008 to that in 2009?
Your response must be concise. 1.34. What is the ratio of the Net Disbursements (current US$) of Poland in 2008 to that in 2009?
Your response must be concise. 0.84. What is the ratio of the Net Disbursements (current US$) of Slovak Republic in 2008 to that in 2009?
Offer a very short reply. 37.35. What is the ratio of the Net Disbursements (current US$) of Czech Republic in 2008 to that in 2010?
Your answer should be very brief. 2.14. What is the ratio of the Net Disbursements (current US$) of Poland in 2008 to that in 2010?
Offer a very short reply. 1.41. What is the ratio of the Net Disbursements (current US$) in Slovak Republic in 2008 to that in 2010?
Ensure brevity in your answer.  18.41. What is the ratio of the Net Disbursements (current US$) in Czech Republic in 2008 to that in 2011?
Your response must be concise. 2.47. What is the ratio of the Net Disbursements (current US$) of Poland in 2008 to that in 2011?
Make the answer very short. 1.08. What is the ratio of the Net Disbursements (current US$) in Slovak Republic in 2008 to that in 2011?
Your response must be concise. 12.82. What is the ratio of the Net Disbursements (current US$) in Czech Republic in 2008 to that in 2012?
Provide a succinct answer. 2.46. What is the ratio of the Net Disbursements (current US$) in Poland in 2008 to that in 2012?
Make the answer very short. 1.13. What is the ratio of the Net Disbursements (current US$) in Slovak Republic in 2008 to that in 2012?
Offer a terse response. 15.16. What is the ratio of the Net Disbursements (current US$) in Czech Republic in 2009 to that in 2010?
Offer a very short reply. 1.6. What is the ratio of the Net Disbursements (current US$) of Poland in 2009 to that in 2010?
Ensure brevity in your answer.  1.67. What is the ratio of the Net Disbursements (current US$) in Slovak Republic in 2009 to that in 2010?
Provide a succinct answer. 0.49. What is the ratio of the Net Disbursements (current US$) of Czech Republic in 2009 to that in 2011?
Ensure brevity in your answer.  1.85. What is the ratio of the Net Disbursements (current US$) of Poland in 2009 to that in 2011?
Offer a terse response. 1.29. What is the ratio of the Net Disbursements (current US$) of Slovak Republic in 2009 to that in 2011?
Your answer should be very brief. 0.34. What is the ratio of the Net Disbursements (current US$) in Czech Republic in 2009 to that in 2012?
Give a very brief answer. 1.84. What is the ratio of the Net Disbursements (current US$) in Poland in 2009 to that in 2012?
Give a very brief answer. 1.34. What is the ratio of the Net Disbursements (current US$) of Slovak Republic in 2009 to that in 2012?
Your answer should be very brief. 0.41. What is the ratio of the Net Disbursements (current US$) in Czech Republic in 2010 to that in 2011?
Give a very brief answer. 1.15. What is the ratio of the Net Disbursements (current US$) in Poland in 2010 to that in 2011?
Offer a very short reply. 0.77. What is the ratio of the Net Disbursements (current US$) in Slovak Republic in 2010 to that in 2011?
Your response must be concise. 0.7. What is the ratio of the Net Disbursements (current US$) in Czech Republic in 2010 to that in 2012?
Make the answer very short. 1.15. What is the ratio of the Net Disbursements (current US$) of Poland in 2010 to that in 2012?
Offer a very short reply. 0.8. What is the ratio of the Net Disbursements (current US$) in Slovak Republic in 2010 to that in 2012?
Give a very brief answer. 0.82. What is the ratio of the Net Disbursements (current US$) in Czech Republic in 2011 to that in 2012?
Your answer should be compact. 0.99. What is the ratio of the Net Disbursements (current US$) of Poland in 2011 to that in 2012?
Your answer should be compact. 1.04. What is the ratio of the Net Disbursements (current US$) of Slovak Republic in 2011 to that in 2012?
Your answer should be compact. 1.18. What is the difference between the highest and the second highest Net Disbursements (current US$) of Czech Republic?
Keep it short and to the point. 1.32e+07. What is the difference between the highest and the second highest Net Disbursements (current US$) of Poland?
Your answer should be very brief. 7.82e+07. What is the difference between the highest and the second highest Net Disbursements (current US$) of Slovak Republic?
Give a very brief answer. 3.91e+06. What is the difference between the highest and the lowest Net Disbursements (current US$) in Czech Republic?
Provide a succinct answer. 4.72e+07. What is the difference between the highest and the lowest Net Disbursements (current US$) of Poland?
Offer a very short reply. 9.30e+07. What is the difference between the highest and the lowest Net Disbursements (current US$) of Slovak Republic?
Your response must be concise. 2.51e+07. 